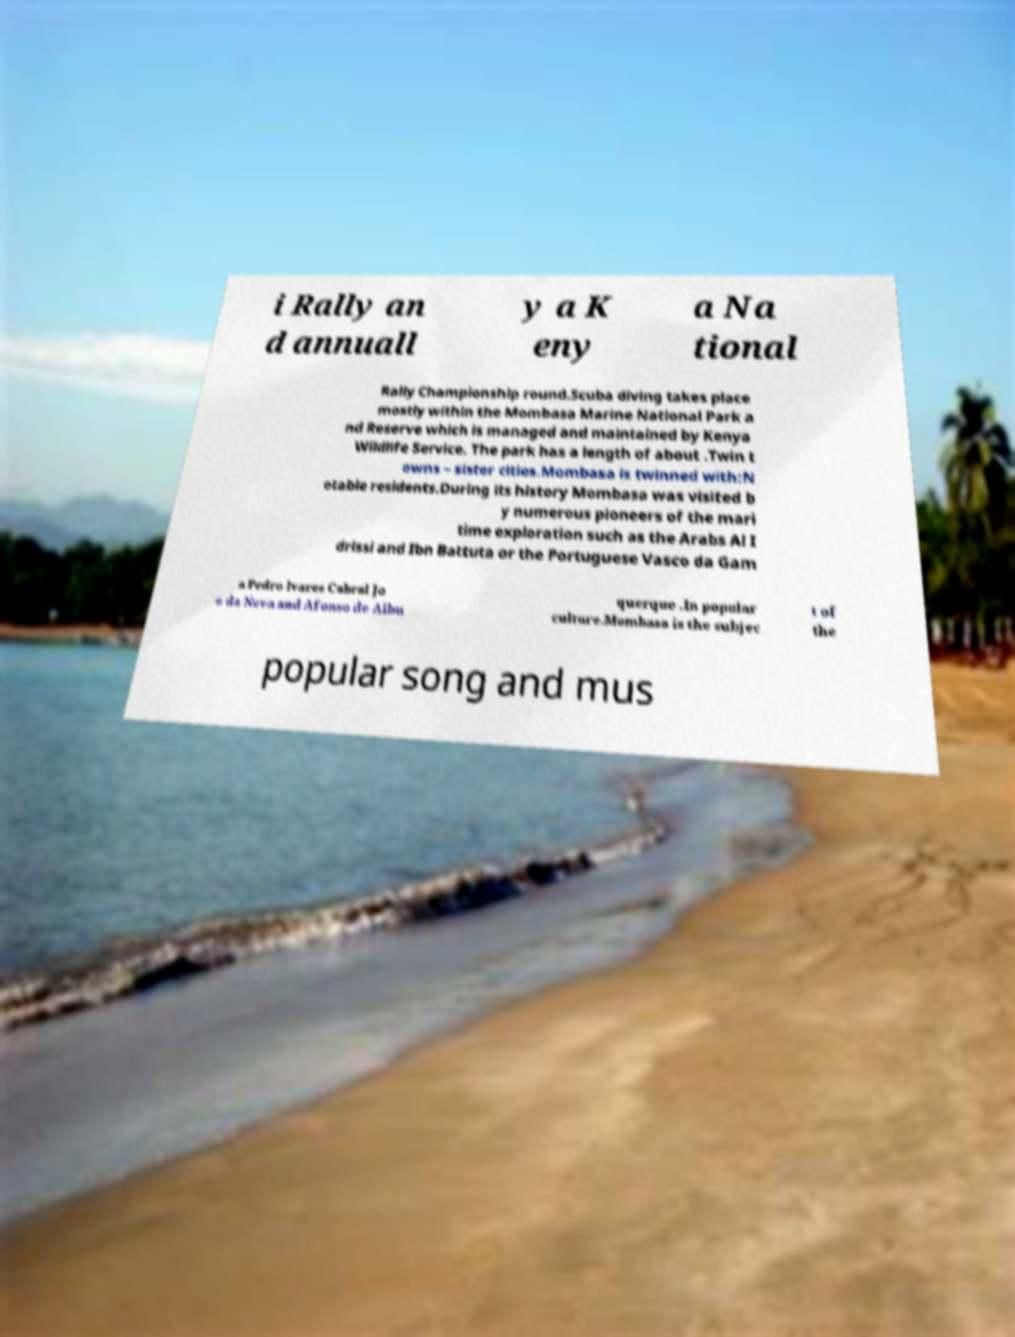Please identify and transcribe the text found in this image. i Rally an d annuall y a K eny a Na tional Rally Championship round.Scuba diving takes place mostly within the Mombasa Marine National Park a nd Reserve which is managed and maintained by Kenya Wildlife Service. The park has a length of about .Twin t owns – sister cities.Mombasa is twinned with:N otable residents.During its history Mombasa was visited b y numerous pioneers of the mari time exploration such as the Arabs Al I drissi and Ibn Battuta or the Portuguese Vasco da Gam a Pedro lvares Cabral Jo o da Nova and Afonso de Albu querque .In popular culture.Mombasa is the subjec t of the popular song and mus 